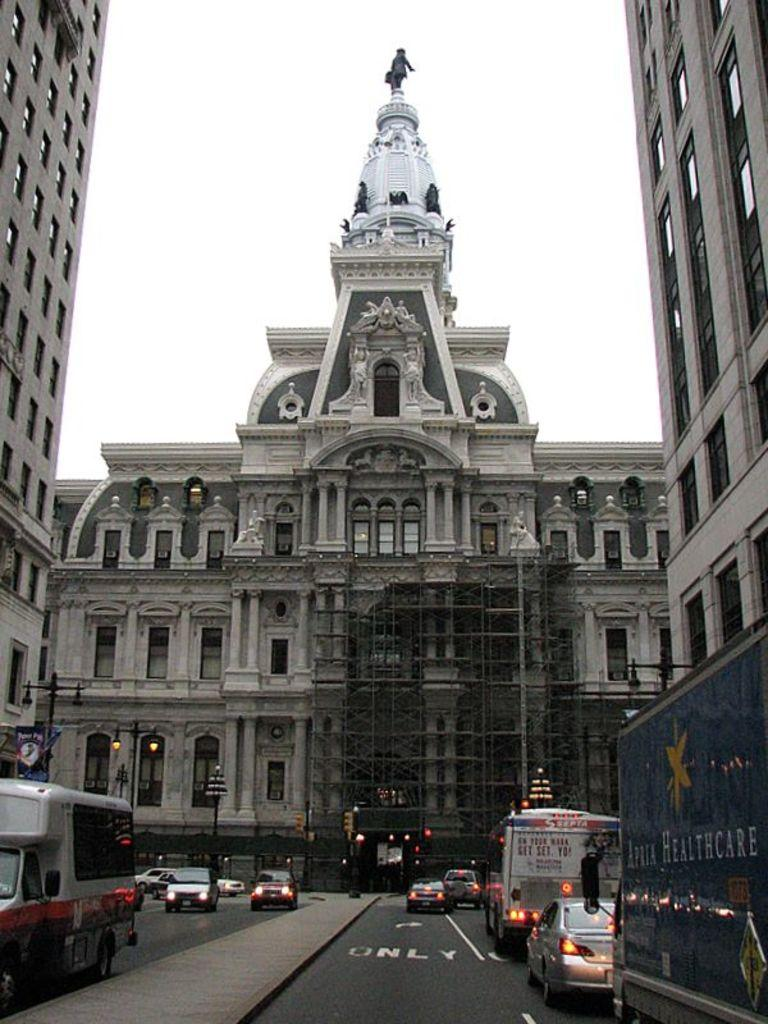What type of structures can be seen in the image? There are buildings in the image. What are the light poles used for in the image? The light poles provide illumination in the image. What are the vehicles doing in the image? The vehicles are on the road in the image. What part of the natural environment is visible in the image? The sky is visible in the image. What type of artwork can be seen in the image? There are statues in the image. What type of advertisements are present in the image? There are hoardings in the image. What else can be seen in the image besides the mentioned elements? There are objects in the image. What type of attraction is the coach taking the passengers to in the image? There is no coach or passengers present in the image, and therefore no such attraction can be observed. How many cars are visible in the image? The term "cars" is not mentioned in the provided facts, so it cannot be determined from the image. 